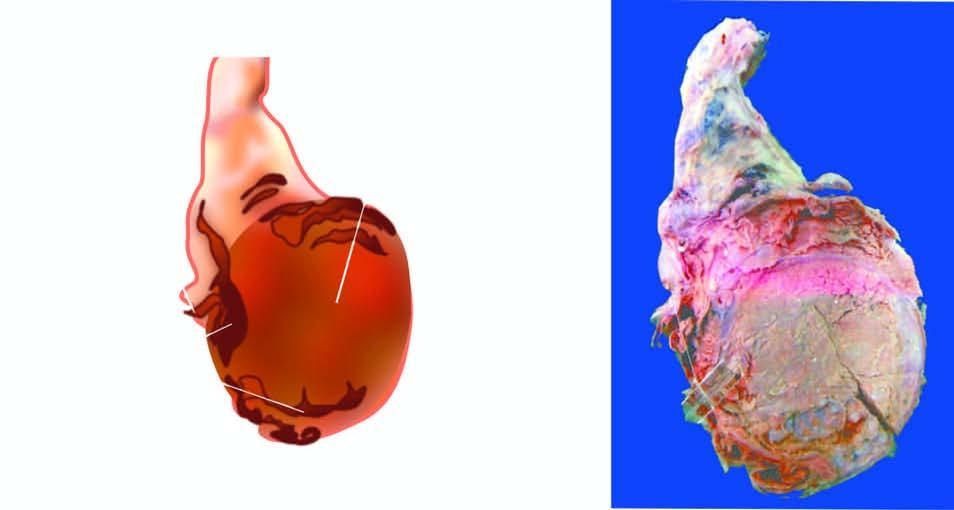how does sectioned surface show replacement of the entire testis?
Answer the question using a single word or phrase. By variegated mass having grey-white solid areas 